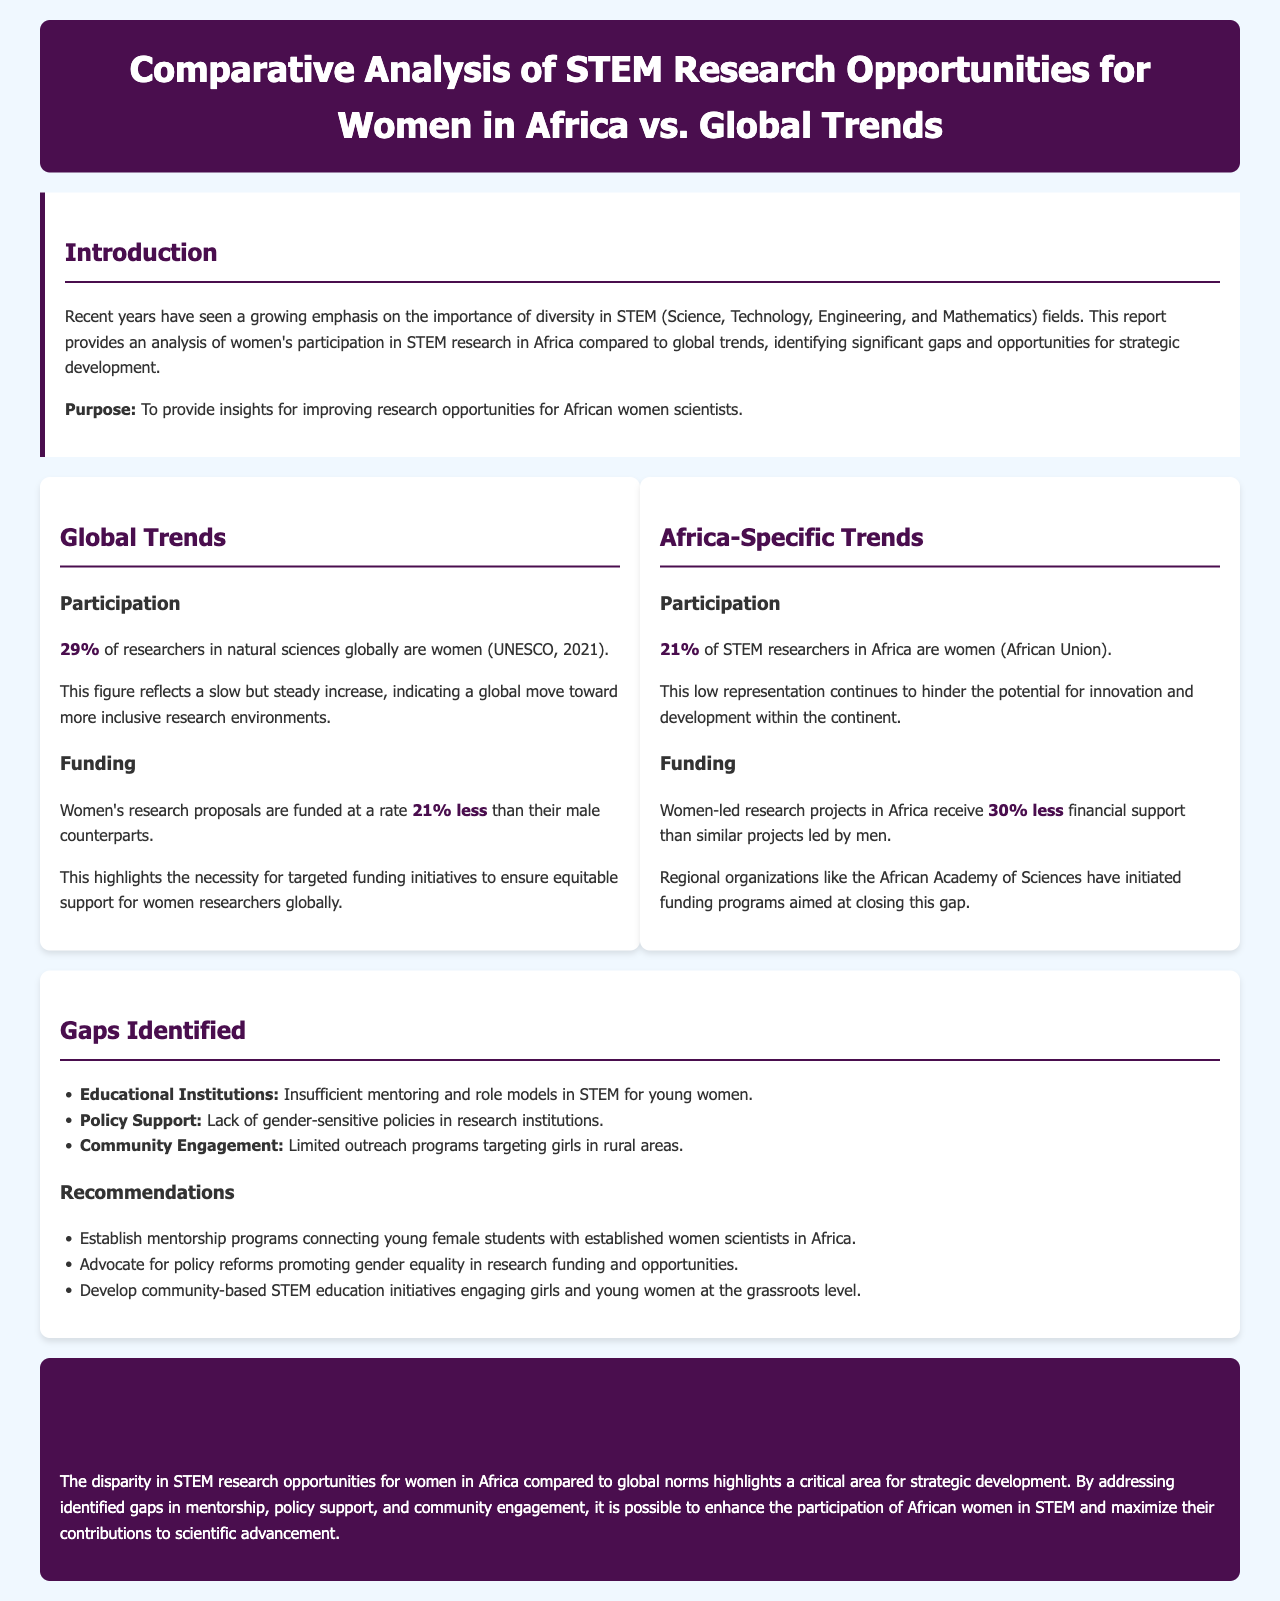what percentage of researchers in natural sciences globally are women? The document states that 29% of researchers in natural sciences globally are women according to UNESCO, 2021.
Answer: 29% what percentage of STEM researchers in Africa are women? The report mentions that 21% of STEM researchers in Africa are women according to the African Union.
Answer: 21% how much less funding do women's research proposals receive compared to men's globally? The report indicates that women's research proposals are funded at a rate 21% less than their male counterparts.
Answer: 21% less what is the financial support difference for women-led research projects in Africa? It is stated that women-led research projects in Africa receive 30% less financial support than similar projects led by men.
Answer: 30% less what is one identified gap in educational institutions regarding women in STEM? The report highlights that there is insufficient mentoring and role models in STEM for young women as a gap in educational institutions.
Answer: Insufficient mentoring what is one recommendation made to improve STEM opportunities for women in Africa? The document recommends establishing mentorship programs connecting young female students with established women scientists in Africa.
Answer: Establish mentorship programs what organization initiated funding programs to close the funding gap for women-led projects in Africa? The African Academy of Sciences is mentioned as a regional organization that has initiated funding programs aimed at closing this gap.
Answer: African Academy of Sciences what is the focus of the conclusion in the report? The conclusion emphasizes addressing identified gaps in mentorship, policy support, and community engagement to enhance the participation of African women in STEM.
Answer: Addressing identified gaps what is the primary purpose of this report? The document states the purpose is to provide insights for improving research opportunities for African women scientists.
Answer: Improving research opportunities 